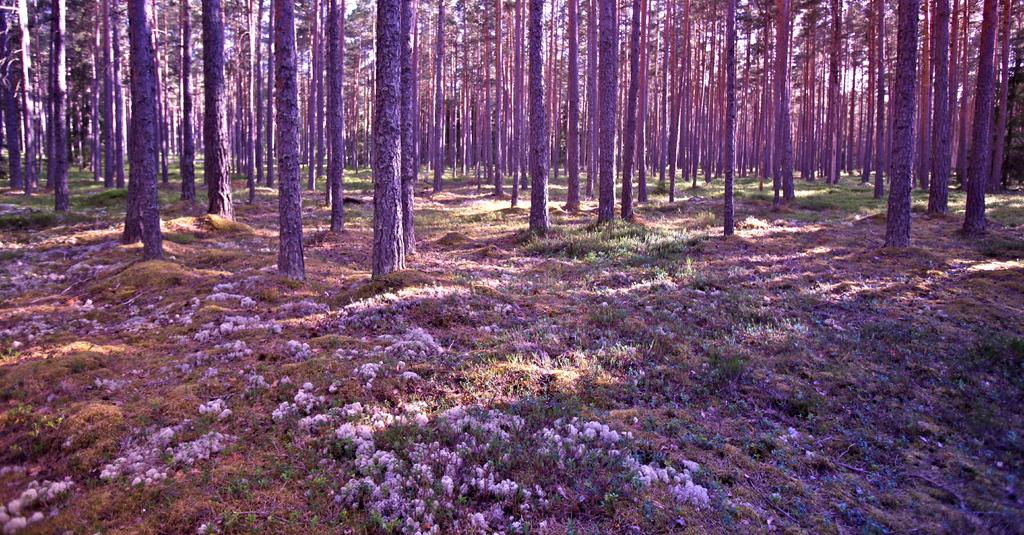What type of vegetation can be seen in the image? There are trees in the image. What is the color of the trees in the image? The trees are green in color. What can be seen in the background of the image? The sky is visible in the background of the image. What is the color of the sky in the image? The sky is white in color. What type of flowers can be seen growing on the trees in the image? There are no flowers mentioned or visible in the image; only trees are present. Can you see a quill being used to write on the trees in the image? There is no quill or writing activity depicted in the image; it only features trees and a white sky. 